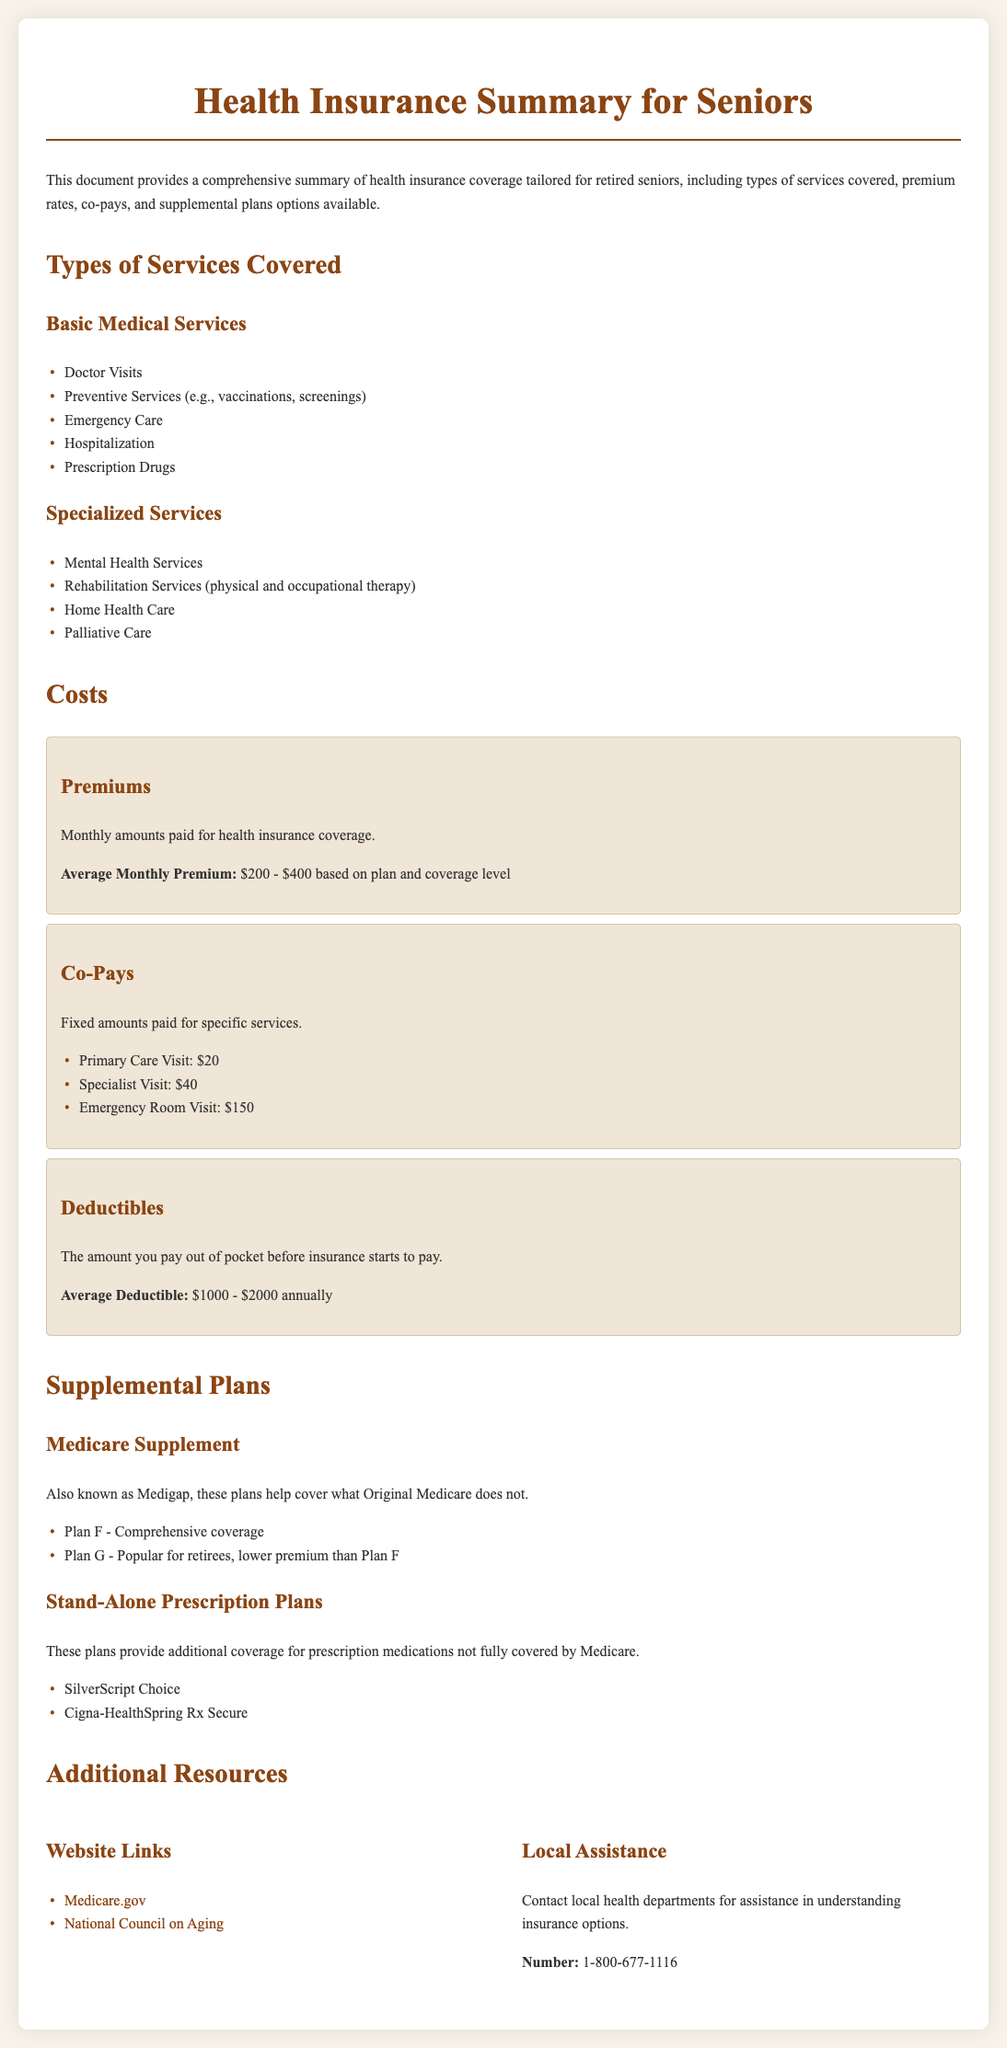What is the title of the document? The title of the document is provided at the top as "Health Insurance Summary for Seniors."
Answer: Health Insurance Summary for Seniors What is the average monthly premium range? The document states the average monthly premium range based on plan and coverage level.
Answer: $200 - $400 What are two examples of specialized services covered? Specialized services include categories of care, and two examples are provided: mental health services and rehabilitation services.
Answer: Mental Health Services, Rehabilitation Services What is the average deductible amount? The document indicates the average deductible amount that seniors can expect to pay before insurance starts covering costs.
Answer: $1000 - $2000 What is Plan G known for? The document describes Plan G in the section for supplemental plans, noting it is popular for retirees and has a lower premium than another plan.
Answer: Lower premium than Plan F What is a fixed amount paid for a specialist visit? The section on co-pays lists fixed amounts for specific services, including the amount for a specialist visit.
Answer: $40 Where can you find local assistance regarding insurance options? The document mentions contacting local health departments for assistance, providing a helpline number.
Answer: 1-800-677-1116 What is the purpose of Medicare Supplement plans? The document explains that these plans help cover what Original Medicare does not, explicitly defining their purpose.
Answer: Help cover what Original Medicare does not What kind of services are included under basic medical services? The document categorizes basic medical services and provides a specific list that includes doctor visits and preventive services.
Answer: Doctor Visits, Preventive Services 